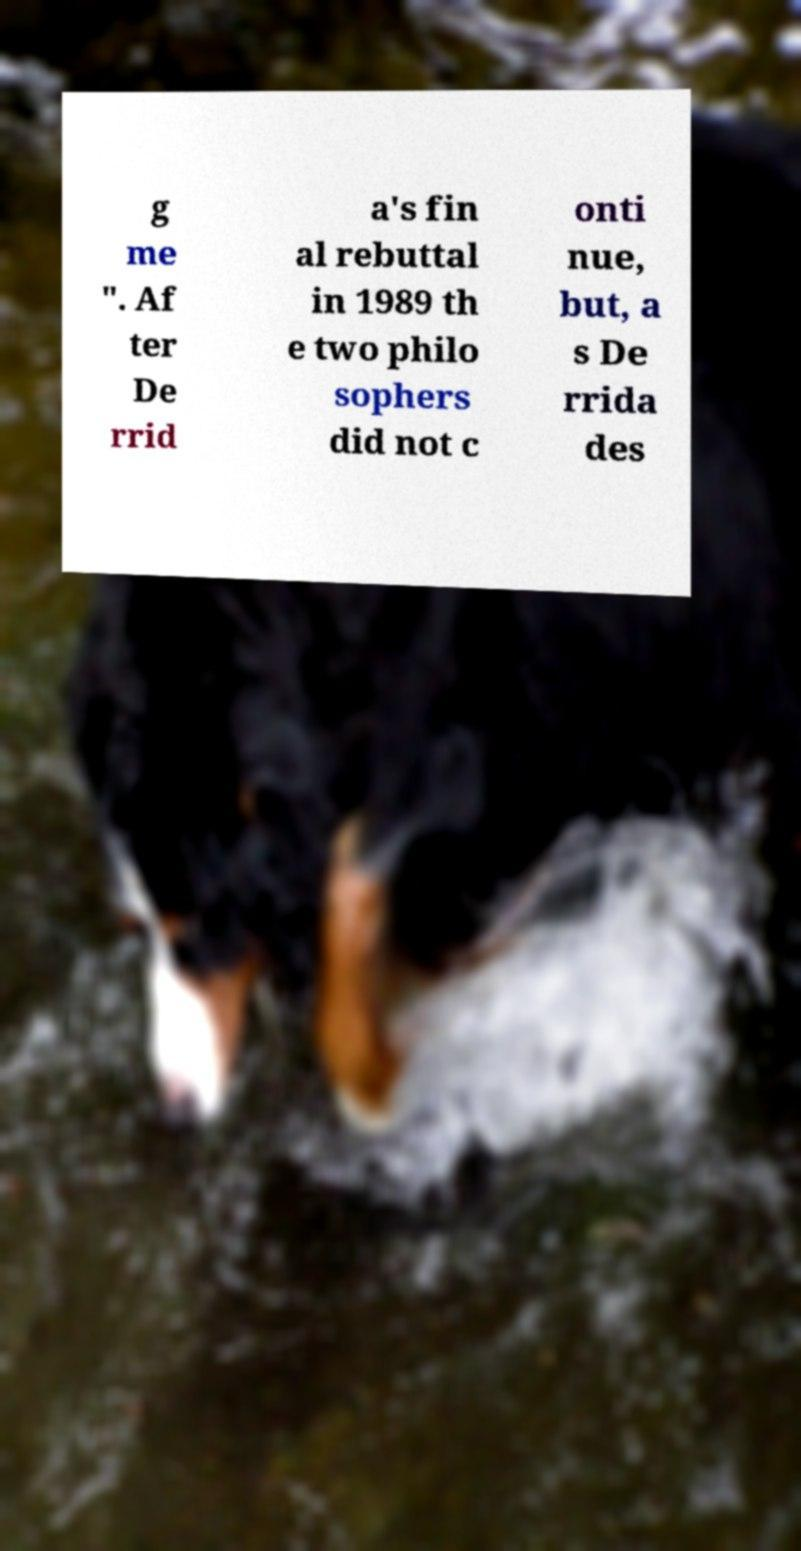I need the written content from this picture converted into text. Can you do that? g me ". Af ter De rrid a's fin al rebuttal in 1989 th e two philo sophers did not c onti nue, but, a s De rrida des 